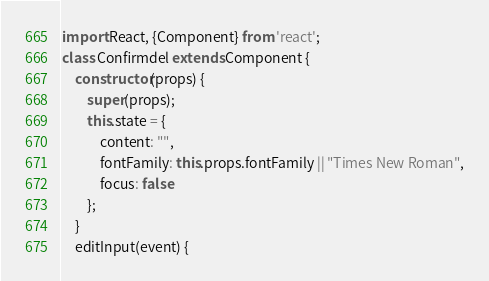<code> <loc_0><loc_0><loc_500><loc_500><_JavaScript_>import React, {Component} from 'react';
class Confirmdel extends Component {
	constructor(props) {
		super(props);
		this.state = {
			content: "",
			fontFamily: this.props.fontFamily || "Times New Roman",
			focus: false
		};
	}
	editInput(event) {</code> 